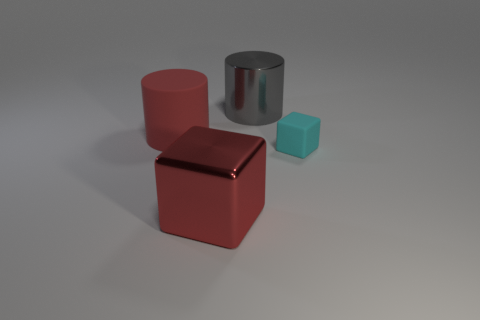Add 2 shiny cylinders. How many objects exist? 6 Subtract 0 yellow cylinders. How many objects are left? 4 Subtract all small cubes. Subtract all blocks. How many objects are left? 1 Add 4 red matte cylinders. How many red matte cylinders are left? 5 Add 2 rubber cubes. How many rubber cubes exist? 3 